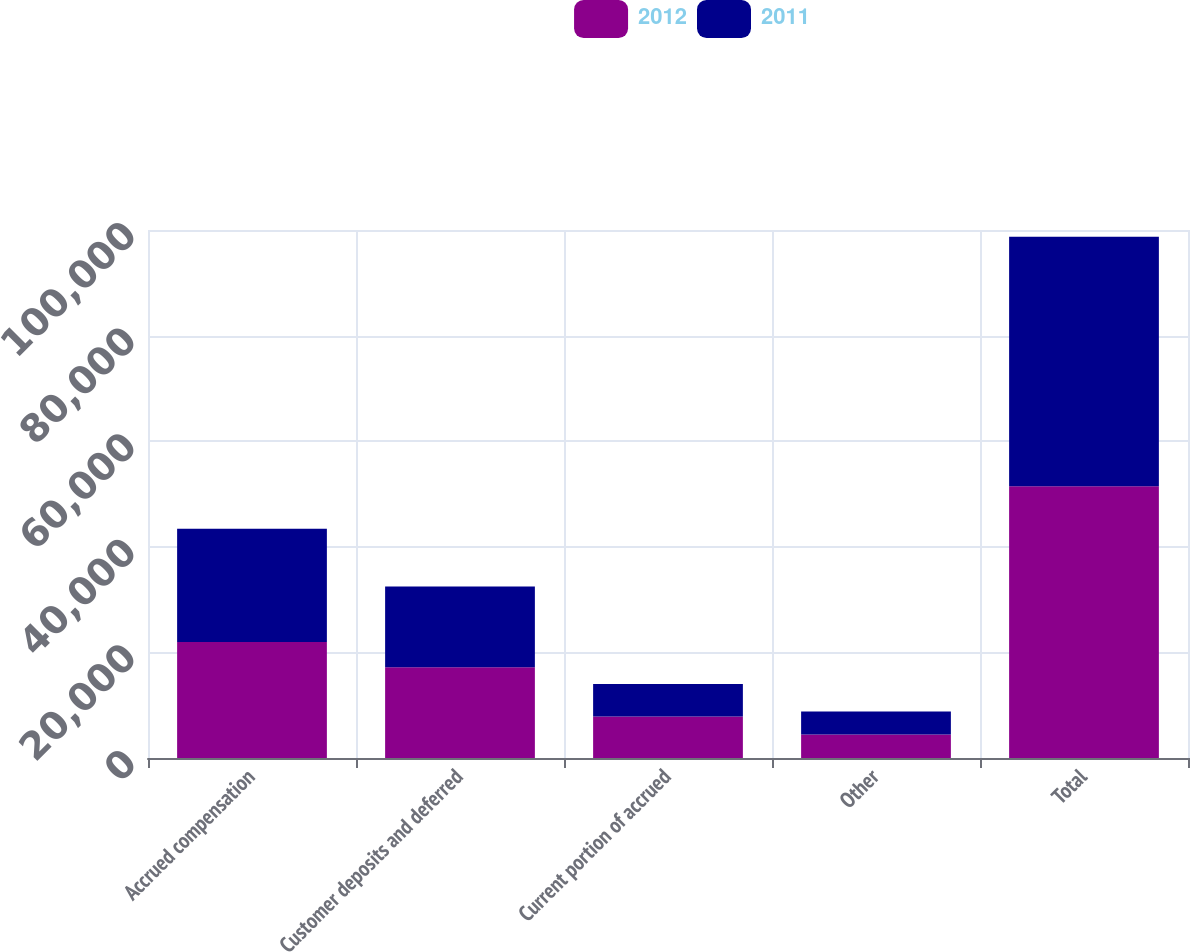Convert chart to OTSL. <chart><loc_0><loc_0><loc_500><loc_500><stacked_bar_chart><ecel><fcel>Accrued compensation<fcel>Customer deposits and deferred<fcel>Current portion of accrued<fcel>Other<fcel>Total<nl><fcel>2012<fcel>21972<fcel>17174<fcel>7838<fcel>4467<fcel>51451<nl><fcel>2011<fcel>21453<fcel>15317<fcel>6186<fcel>4329<fcel>47285<nl></chart> 